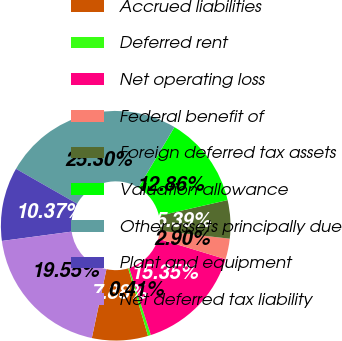<chart> <loc_0><loc_0><loc_500><loc_500><pie_chart><fcel>Accrued liabilities<fcel>Deferred rent<fcel>Net operating loss<fcel>Federal benefit of<fcel>Foreign deferred tax assets<fcel>Valuation allowance<fcel>Other assets principally due<fcel>Plant and equipment<fcel>Net deferred tax liability<nl><fcel>7.88%<fcel>0.41%<fcel>15.35%<fcel>2.9%<fcel>5.39%<fcel>12.86%<fcel>25.3%<fcel>10.37%<fcel>19.55%<nl></chart> 